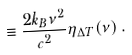Convert formula to latex. <formula><loc_0><loc_0><loc_500><loc_500>\equiv \frac { 2 k _ { B } \nu ^ { 2 } } { c ^ { 2 } } \eta _ { \Delta T } ( \nu ) \, .</formula> 